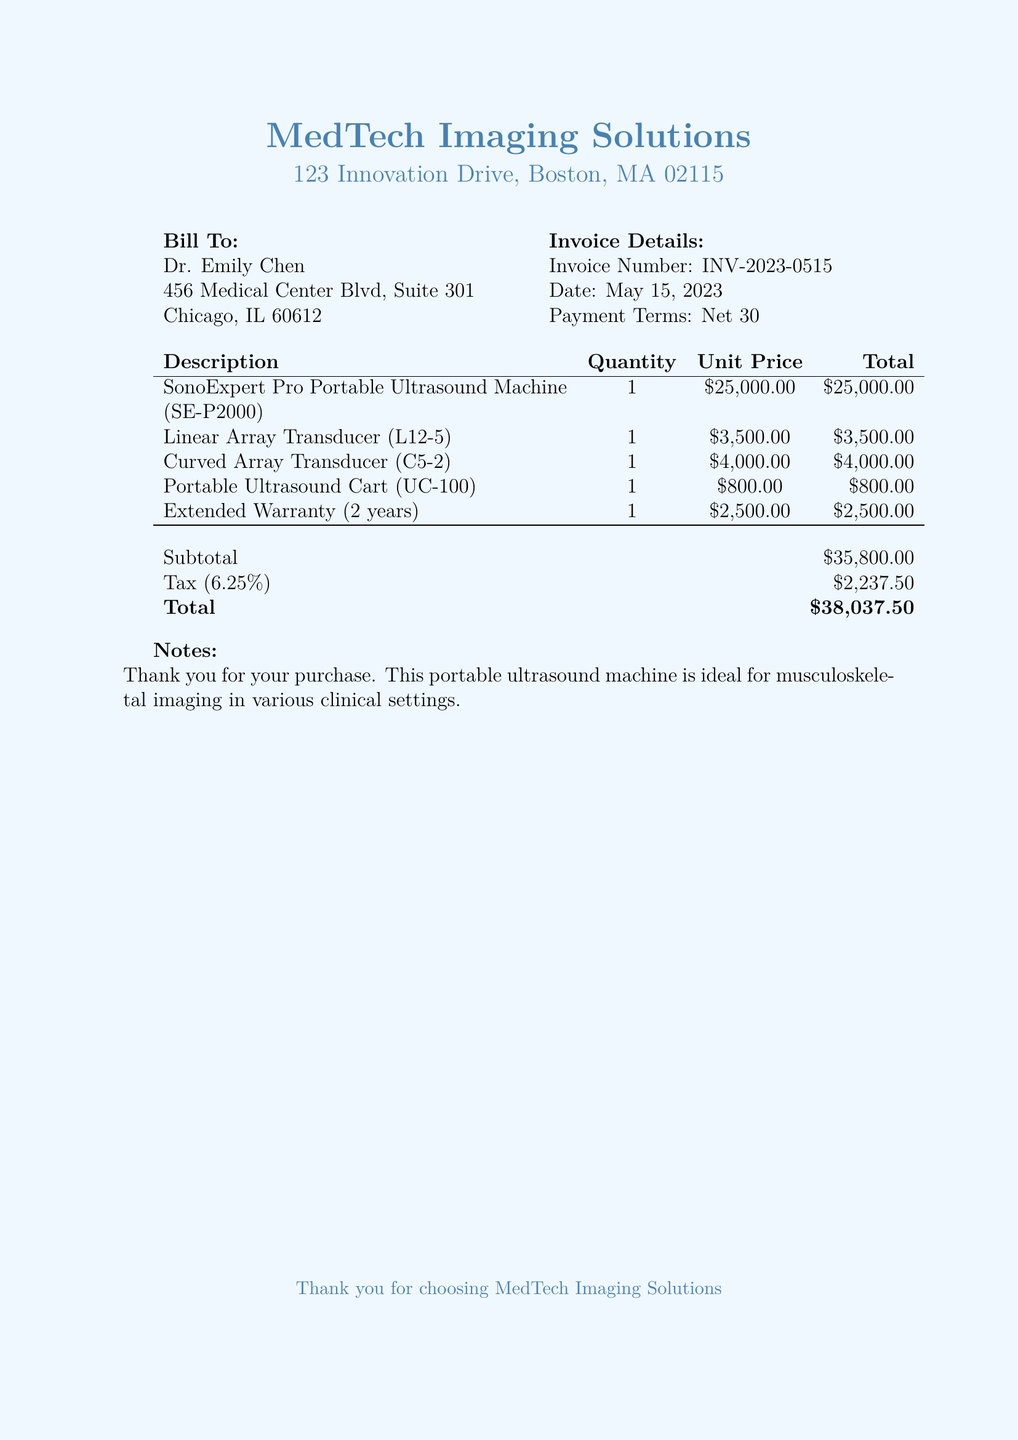What is the total amount due? The total amount due is stated at the bottom of the document, which includes all item prices, tax, and any additional fees.
Answer: $38,037.50 What is the invoice number? The invoice number is provided in the invoice details section of the document.
Answer: INV-2023-0515 How much is the tax amount? The tax amount is calculated based on the subtotal and is shown clearly in the invoice breakdown.
Answer: $2,237.50 What is the unit price of the portable ultrasound machine? The unit price is listed in the itemized section for the SonoExpert Pro Portable Ultrasound Machine.
Answer: $25,000.00 How long is the extended warranty? The extended warranty duration is specified in the description of the warranty line item.
Answer: 2 years Who is the bill addressed to? The bill is addressed to the individual or entity listed under the "Bill To" section at the beginning of the document.
Answer: Dr. Emily Chen What are the payment terms? The payment terms are specified just after the invoice details in the document, showing when payment is expected.
Answer: Net 30 What is the quantity of the Linear Array Transducer? The quantity is shown in the itemized list under the respective accessory in the document.
Answer: 1 What color is used for the document header? The header color is described specifically within the document as a defined RGB shade.
Answer: RGB(70,130,180) 